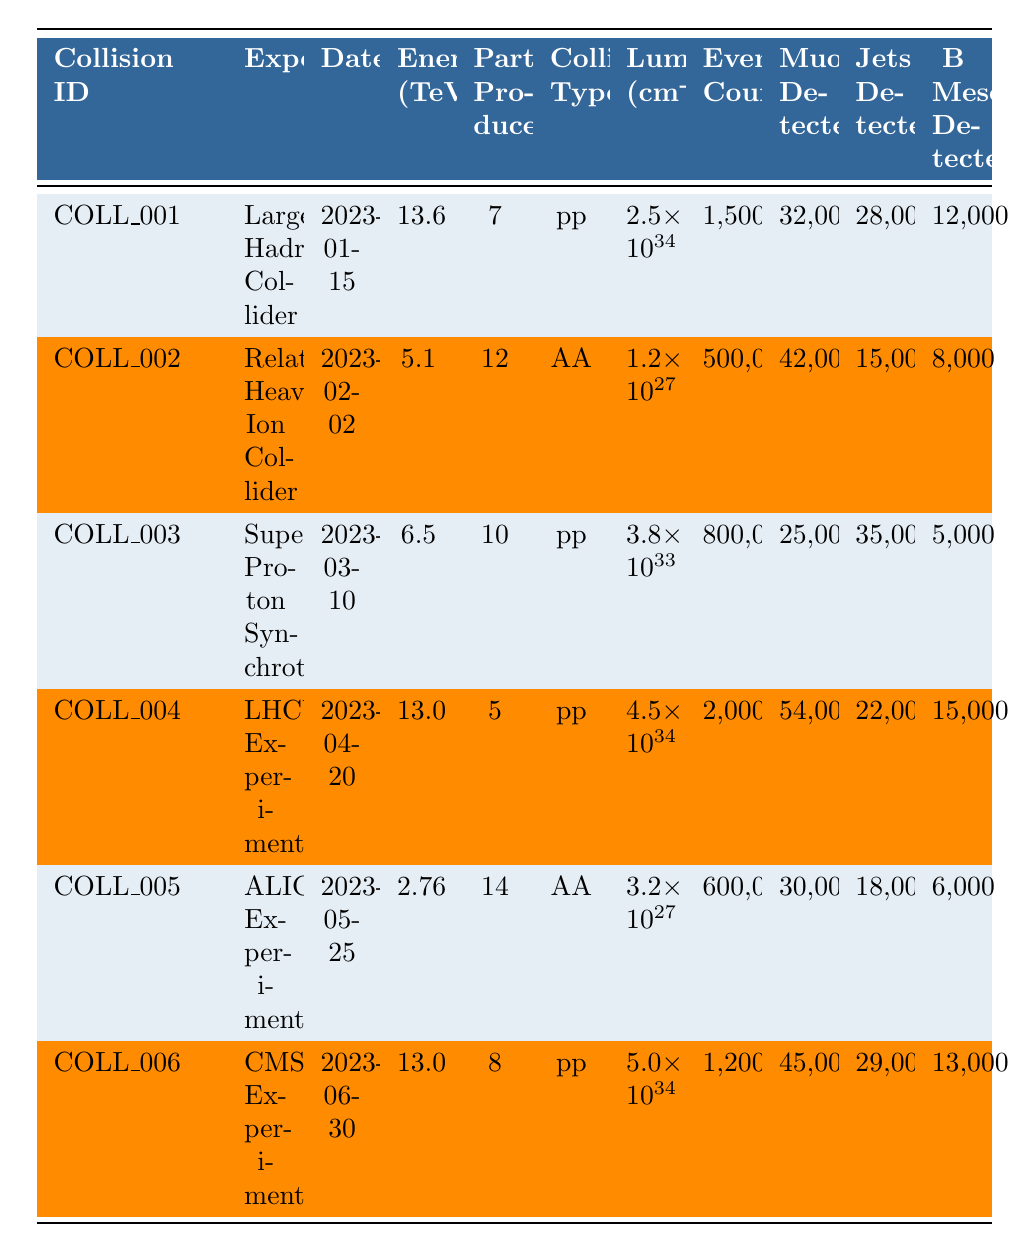What is the maximum energy recorded in the collisions? The maximum energy listed in the table is 13.6 TeV, found under collision COLL_001 with the Large Hadron Collider.
Answer: 13.6 TeV What experiment was conducted on 2023-04-20? On this date, the experiment listed is the LHCb Experiment, associated with collision COLL_004.
Answer: LHCb Experiment How many jets were detected in the ALICE Experiment? The ALICE Experiment, associated with COLL_005, had 18,000 jets detected listed in the table.
Answer: 18,000 Which collision type produced the highest number of b mesons? COLL_004 (LHCb Experiment) had the highest count of b mesons detected, with a total of 15,000 observed.
Answer: 15,000 What is the average number of particles produced across all collisions? Sum the particles produced: 7 + 12 + 10 + 5 + 14 + 8 = 56. There are 6 collisions, thus the average is 56/6 = 9.33.
Answer: 9.33 Is the luminosity of COLL_002 greater than that of COLL_006? The luminosity of COLL_002 is 1.2e27, and COLL_006 is 5.0e34. Since 5.0e34 > 1.2e27, the statement is false.
Answer: No What is the total number of events recorded for 'pp' collision types? COLL_001 has 1,500,000 and COLL_003 has 800,000 and COLL_004 has 2,000,000. Summing these gives 1,500,000 + 800,000 + 2,000,000 = 4,300,000.
Answer: 4,300,000 Which experiment had the lowest luminosity? The ALICE Experiment (COLL_005) had the lowest luminosity of 3.2e27, compared to all others listed in the table.
Answer: ALICE Experiment How many muons were detected in collisions with an energy of 13 TeV or higher? COLL_001 had 32,000 muons and COLL_006 had 45,000 muons. Summing these gives 32,000 + 45,000 = 77,000.
Answer: 77,000 What proportion of the event count had muons detected in the Large Hadron Collider? For COLL_001, there are 1,500,000 events and 32,000 muons, so the proportion is 32,000/1,500,000 = 0.021333 or 2.1333%.
Answer: 2.13% 